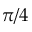Convert formula to latex. <formula><loc_0><loc_0><loc_500><loc_500>\pi / 4</formula> 